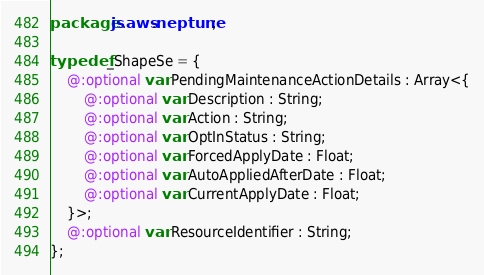<code> <loc_0><loc_0><loc_500><loc_500><_Haxe_>package js.aws.neptune;

typedef _ShapeSe = {
    @:optional var PendingMaintenanceActionDetails : Array<{
        @:optional var Description : String;
        @:optional var Action : String;
        @:optional var OptInStatus : String;
        @:optional var ForcedApplyDate : Float;
        @:optional var AutoAppliedAfterDate : Float;
        @:optional var CurrentApplyDate : Float;
    }>;
    @:optional var ResourceIdentifier : String;
};
</code> 